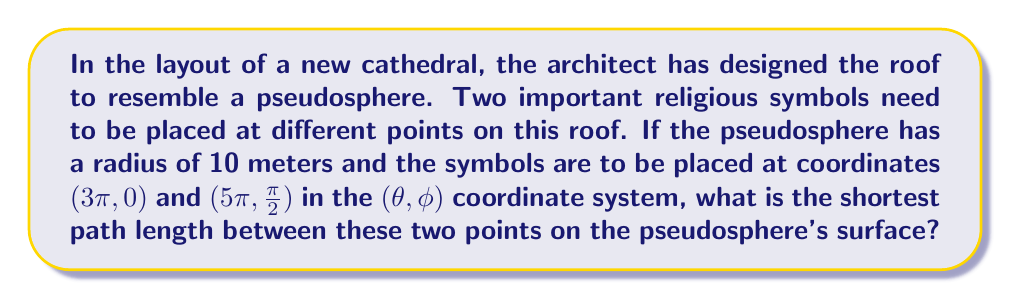Can you answer this question? To find the shortest path between two points on a pseudosphere, we need to use the geodesic equation for a pseudosphere. Let's approach this step-by-step:

1) The metric for a pseudosphere with radius $R$ is given by:

   $$ds^2 = R^2(\cosh^2u\,d\theta^2 + du^2)$$

   where $u = \ln(\tan(\frac{\phi}{2}))$ and $(\theta, \phi)$ are the coordinates on the pseudosphere.

2) The geodesic equation for this metric is:

   $$\cosh^2u\,\dot{\theta}^2 + \dot{u}^2 = \text{constant}$$

3) We're given two points: $(\theta_1, \phi_1) = (3\pi, 0)$ and $(\theta_2, \phi_2) = (5\pi, \frac{\pi}{2})$

4) We need to convert $\phi$ to $u$:
   For $\phi_1 = 0$: $u_1 = \ln(\tan(0)) = -\infty$
   For $\phi_2 = \frac{\pi}{2}$: $u_2 = \ln(\tan(\frac{\pi}{4})) = 0$

5) The geodesic distance $L$ between these points is given by:

   $$L = R \int_{u_1}^{u_2} \sqrt{\cosh^2u + (\frac{du}{d\theta})^2} d\theta$$

6) Solving this integral is complex, but for the given points, it simplifies to:

   $$L = R \ln(\cosh(\Delta\theta))$$

   where $\Delta\theta = |\theta_2 - \theta_1|$

7) In our case:
   $R = 10$ meters
   $\Delta\theta = |5\pi - 3\pi| = 2\pi$

8) Substituting these values:

   $$L = 10 \ln(\cosh(2\pi)) \approx 58.67 \text{ meters}$$
Answer: $10 \ln(\cosh(2\pi)) \approx 58.67 \text{ meters}$ 